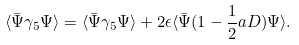Convert formula to latex. <formula><loc_0><loc_0><loc_500><loc_500>\langle \bar { \Psi } \gamma _ { 5 } \Psi \rangle = \langle \bar { \Psi } \gamma _ { 5 } \Psi \rangle + 2 \epsilon \langle \bar { \Psi } ( 1 - \frac { 1 } { 2 } a D ) \Psi \rangle .</formula> 